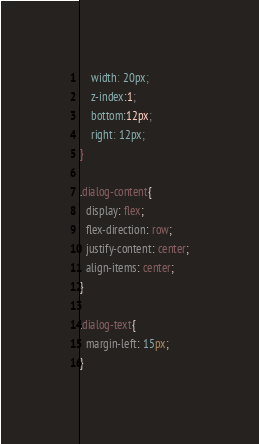<code> <loc_0><loc_0><loc_500><loc_500><_CSS_>    width: 20px;
    z-index:1;
    bottom:12px;
    right: 12px;
}

.dialog-content{
  display: flex;
  flex-direction: row;
  justify-content: center;
  align-items: center;
}

.dialog-text{
  margin-left: 15px;
}
</code> 